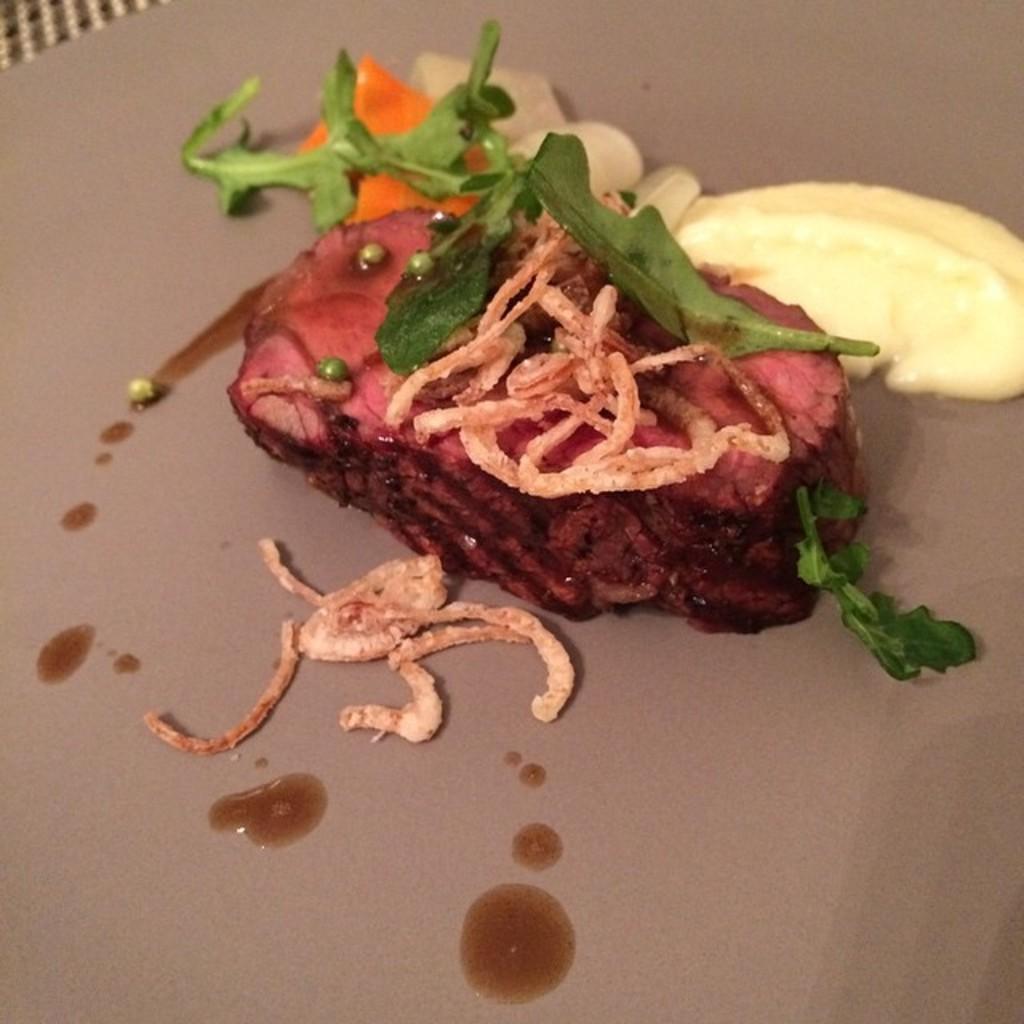How would you summarize this image in a sentence or two? In this image, we can see some food on the plate. 